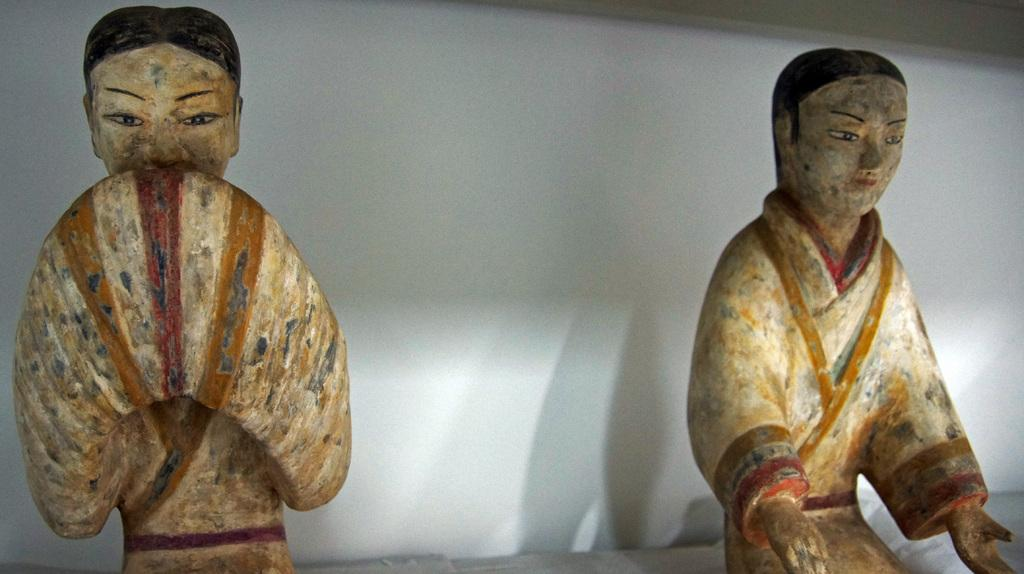How many sculptures can be seen in the image? There are 2 sculptures in the image. What can be observed in the background of the image? The background of the image is white. What type of steel is used to create the sculptures in the image? There is no information about the material used to create the sculptures in the image, so it cannot be determined if steel is used. 